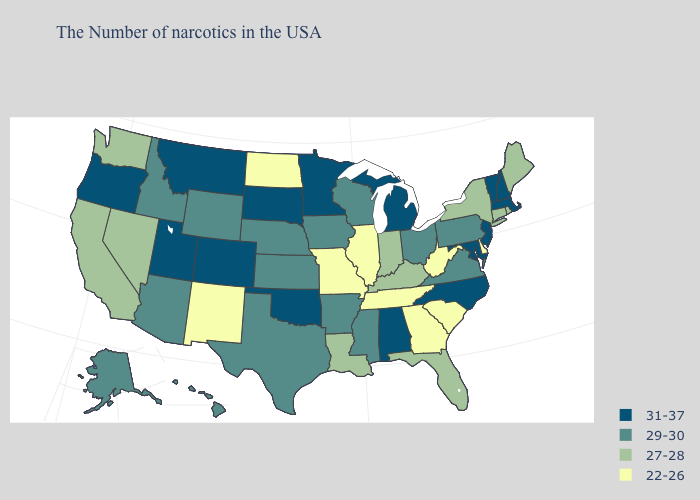Name the states that have a value in the range 27-28?
Be succinct. Maine, Rhode Island, Connecticut, New York, Florida, Kentucky, Indiana, Louisiana, Nevada, California, Washington. Name the states that have a value in the range 29-30?
Answer briefly. Pennsylvania, Virginia, Ohio, Wisconsin, Mississippi, Arkansas, Iowa, Kansas, Nebraska, Texas, Wyoming, Arizona, Idaho, Alaska, Hawaii. Name the states that have a value in the range 22-26?
Write a very short answer. Delaware, South Carolina, West Virginia, Georgia, Tennessee, Illinois, Missouri, North Dakota, New Mexico. What is the lowest value in the MidWest?
Keep it brief. 22-26. Among the states that border Kansas , does Missouri have the lowest value?
Short answer required. Yes. Does Rhode Island have a lower value than New Jersey?
Be succinct. Yes. Among the states that border Arkansas , does Mississippi have the lowest value?
Quick response, please. No. What is the value of New Mexico?
Be succinct. 22-26. What is the highest value in the South ?
Concise answer only. 31-37. Name the states that have a value in the range 31-37?
Concise answer only. Massachusetts, New Hampshire, Vermont, New Jersey, Maryland, North Carolina, Michigan, Alabama, Minnesota, Oklahoma, South Dakota, Colorado, Utah, Montana, Oregon. Name the states that have a value in the range 27-28?
Answer briefly. Maine, Rhode Island, Connecticut, New York, Florida, Kentucky, Indiana, Louisiana, Nevada, California, Washington. Does Louisiana have a lower value than Oklahoma?
Short answer required. Yes. Does New Jersey have the same value as Iowa?
Quick response, please. No. 